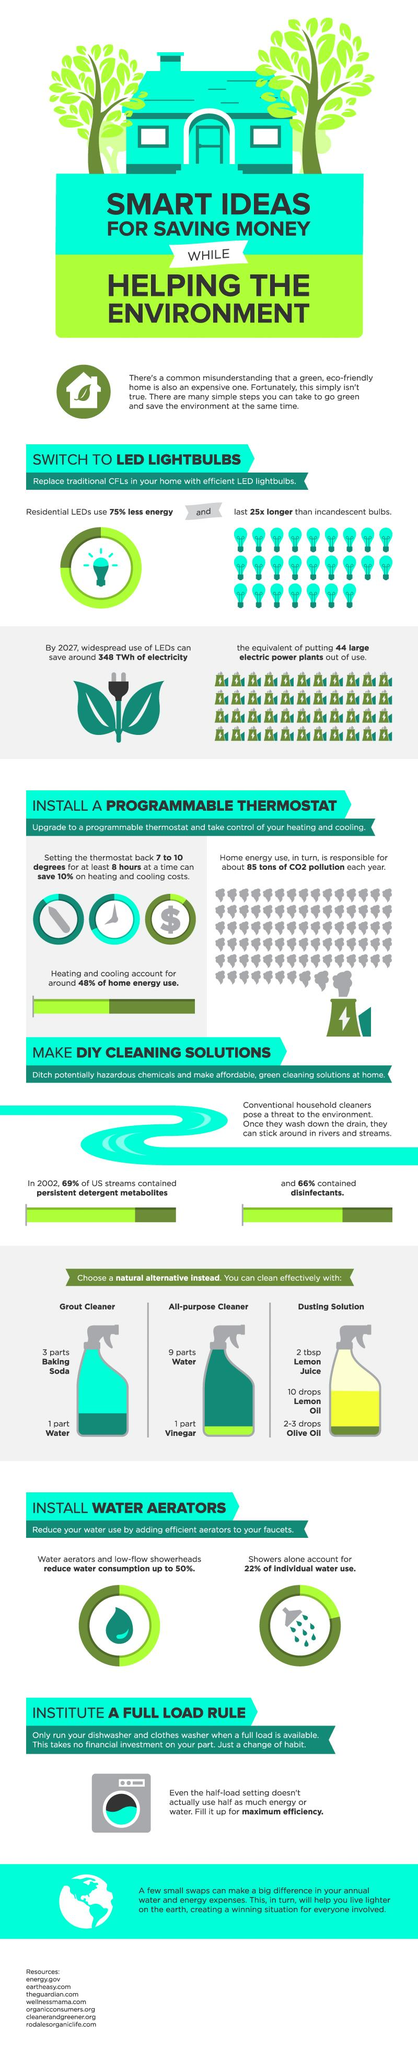Indicate a few pertinent items in this graphic. All purpose cleaners and grout cleaners contain a common ingredient: water. 